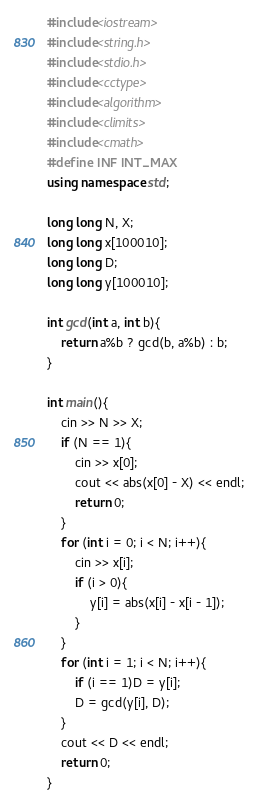Convert code to text. <code><loc_0><loc_0><loc_500><loc_500><_C++_>#include<iostream>
#include<string.h>
#include<stdio.h>
#include<cctype>
#include<algorithm>
#include<climits>
#include<cmath>
#define INF INT_MAX
using namespace std;

long long N, X;
long long x[100010];
long long D;
long long y[100010];

int gcd(int a, int b){
	return a%b ? gcd(b, a%b) : b;
}

int main(){
	cin >> N >> X;
	if (N == 1){
		cin >> x[0];
		cout << abs(x[0] - X) << endl;
		return 0;
	}
	for (int i = 0; i < N; i++){
		cin >> x[i];
		if (i > 0){
			y[i] = abs(x[i] - x[i - 1]);
		}
	}
	for (int i = 1; i < N; i++){
		if (i == 1)D = y[i];
		D = gcd(y[i], D);
	}
	cout << D << endl;
	return 0;
}</code> 